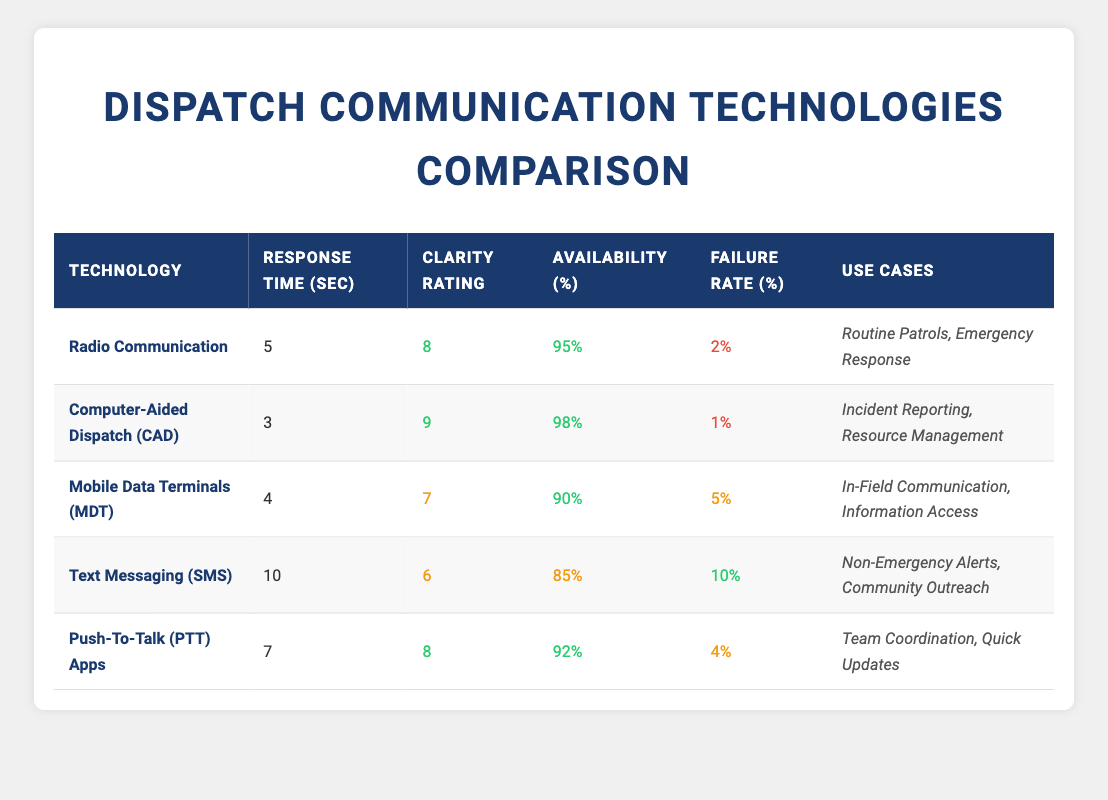What is the response time for Computer-Aided Dispatch (CAD)? The table lists "Computer-Aided Dispatch (CAD)" under the technology column, and the corresponding response time is shown as 3 seconds.
Answer: 3 seconds Which technology has the highest clarity rating? The clarity ratings are as follows: Radio Communication (8), Computer-Aided Dispatch (9), Mobile Data Terminals (7), Text Messaging (6), and Push-To-Talk (8). The highest value is 9, which corresponds to Computer-Aided Dispatch.
Answer: Computer-Aided Dispatch Is the failure rate for Mobile Data Terminals (MDT) higher than 5%? The failure rate for Mobile Data Terminals (MDT) is listed as 5%. Since the question asks if it is higher than 5%, the answer is no.
Answer: No What is the average availability percentage across all technologies? The availability percentages are: Radio Communication (95%), CAD (98%), MDT (90%), Text Messaging (85%), and PTT Apps (92%). To find the average, we sum these values: 95 + 98 + 90 + 85 + 92 = 460. There are 5 technologies, so the average is 460/5 = 92%.
Answer: 92% For which technology is the response time the longest? Looking at the response times: Radio Communication (5 sec), CAD (3 sec), MDT (4 sec), Text Messaging (10 sec), and PTT Apps (7 sec), Text Messaging has the longest response time of 10 seconds.
Answer: Text Messaging What is the failure rate gap between Computer-Aided Dispatch (CAD) and Push-To-Talk (PTT) Apps? The failure rates are CAD (1%) and PTT Apps (4%). The gap is calculated by subtracting CAD's failure rate from PTT's, so 4% - 1% = 3%.
Answer: 3% Which use case is associated with Mobile Data Terminals (MDT)? Referring to the table, the use cases for Mobile Data Terminals (MDT) are listed as "In-Field Communication" and "Information Access." These describe the roles that MDT plays in communication and information management.
Answer: In-Field Communication, Information Access Is there any technology with a response time less than 4 seconds? The response times are as follows: Radio Communication (5 sec), CAD (3 sec), MDT (4 sec), Text Messaging (10 sec), and PTT Apps (7 sec). CAD is the only technology with a response time less than 4 seconds.
Answer: Yes How many technologies have a clarity rating of 8 or above? The technologies with clarity ratings of 8 or above are: Radio Communication (8), Computer-Aided Dispatch (9), and Push-To-Talk (8) — totaling 3 technologies.
Answer: 3 